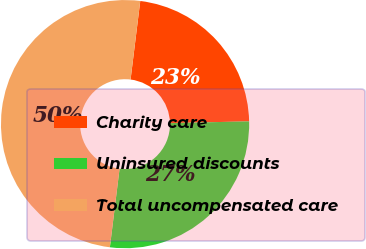Convert chart. <chart><loc_0><loc_0><loc_500><loc_500><pie_chart><fcel>Charity care<fcel>Uninsured discounts<fcel>Total uncompensated care<nl><fcel>22.69%<fcel>27.31%<fcel>50.0%<nl></chart> 